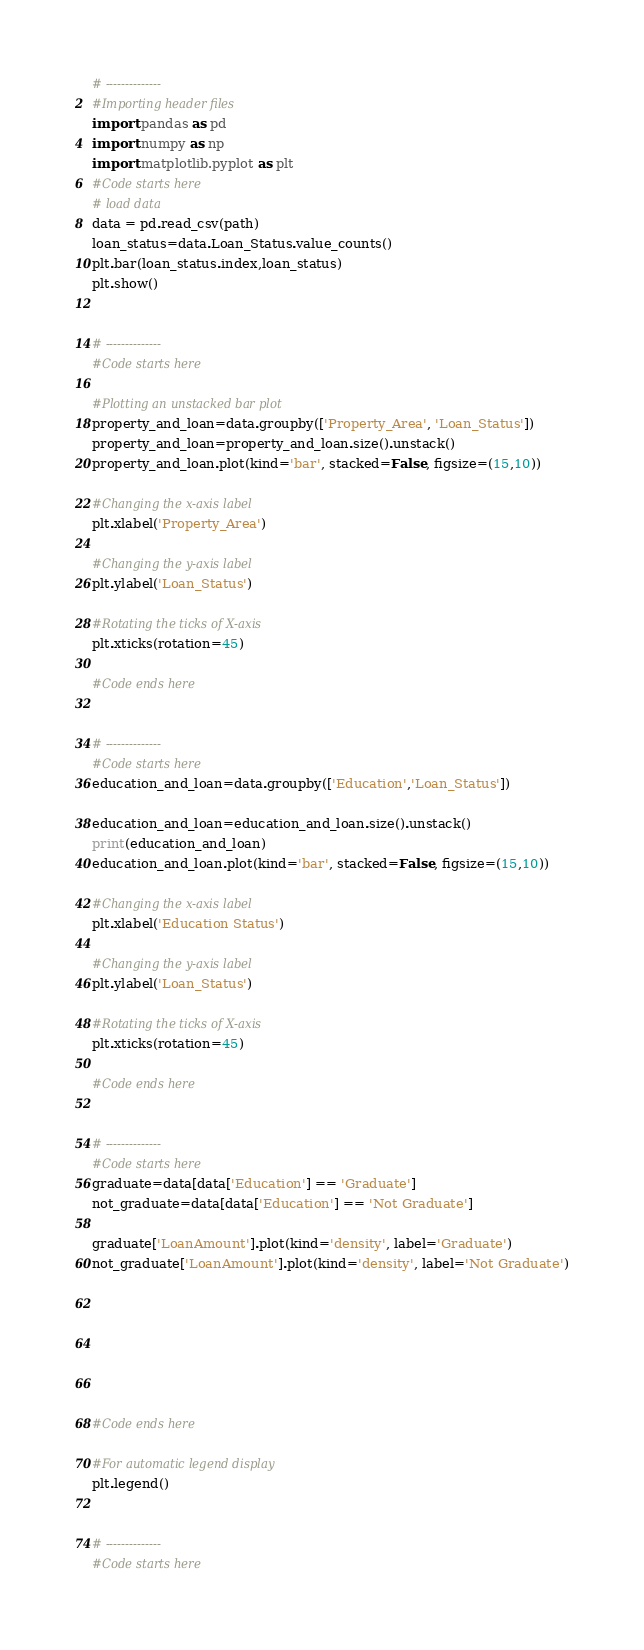Convert code to text. <code><loc_0><loc_0><loc_500><loc_500><_Python_># --------------
#Importing header files
import pandas as pd
import numpy as np
import matplotlib.pyplot as plt
#Code starts here
# load data
data = pd.read_csv(path)
loan_status=data.Loan_Status.value_counts()
plt.bar(loan_status.index,loan_status)
plt.show()


# --------------
#Code starts here

#Plotting an unstacked bar plot
property_and_loan=data.groupby(['Property_Area', 'Loan_Status'])
property_and_loan=property_and_loan.size().unstack()
property_and_loan.plot(kind='bar', stacked=False, figsize=(15,10))

#Changing the x-axis label
plt.xlabel('Property_Area')

#Changing the y-axis label
plt.ylabel('Loan_Status')

#Rotating the ticks of X-axis
plt.xticks(rotation=45)

#Code ends here


# --------------
#Code starts here
education_and_loan=data.groupby(['Education','Loan_Status'])

education_and_loan=education_and_loan.size().unstack()
print(education_and_loan)
education_and_loan.plot(kind='bar', stacked=False, figsize=(15,10))

#Changing the x-axis label
plt.xlabel('Education Status')

#Changing the y-axis label
plt.ylabel('Loan_Status')

#Rotating the ticks of X-axis
plt.xticks(rotation=45)

#Code ends here


# --------------
#Code starts here
graduate=data[data['Education'] == 'Graduate']
not_graduate=data[data['Education'] == 'Not Graduate']

graduate['LoanAmount'].plot(kind='density', label='Graduate')
not_graduate['LoanAmount'].plot(kind='density', label='Not Graduate')







#Code ends here

#For automatic legend display
plt.legend()


# --------------
#Code starts here</code> 